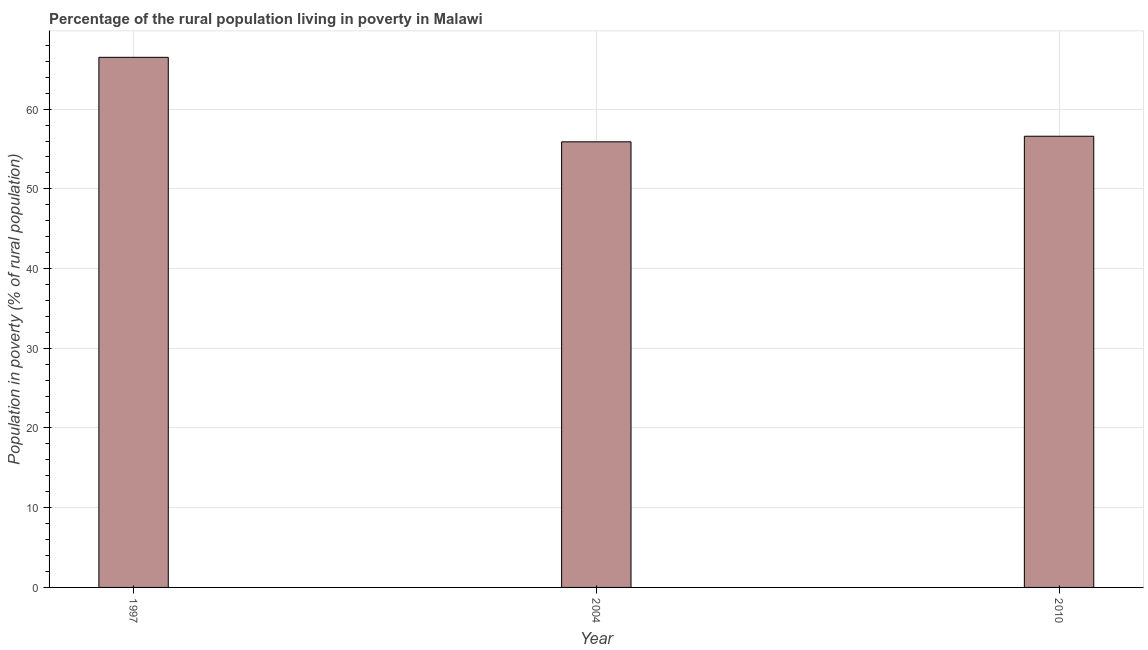What is the title of the graph?
Ensure brevity in your answer.  Percentage of the rural population living in poverty in Malawi. What is the label or title of the X-axis?
Provide a short and direct response. Year. What is the label or title of the Y-axis?
Provide a short and direct response. Population in poverty (% of rural population). What is the percentage of rural population living below poverty line in 2004?
Make the answer very short. 55.9. Across all years, what is the maximum percentage of rural population living below poverty line?
Your response must be concise. 66.5. Across all years, what is the minimum percentage of rural population living below poverty line?
Keep it short and to the point. 55.9. In which year was the percentage of rural population living below poverty line maximum?
Provide a short and direct response. 1997. In which year was the percentage of rural population living below poverty line minimum?
Provide a short and direct response. 2004. What is the sum of the percentage of rural population living below poverty line?
Provide a succinct answer. 179. What is the difference between the percentage of rural population living below poverty line in 1997 and 2010?
Provide a succinct answer. 9.9. What is the average percentage of rural population living below poverty line per year?
Make the answer very short. 59.67. What is the median percentage of rural population living below poverty line?
Make the answer very short. 56.6. In how many years, is the percentage of rural population living below poverty line greater than 18 %?
Your answer should be very brief. 3. Do a majority of the years between 2010 and 2004 (inclusive) have percentage of rural population living below poverty line greater than 38 %?
Your response must be concise. No. What is the ratio of the percentage of rural population living below poverty line in 1997 to that in 2004?
Offer a very short reply. 1.19. Is the difference between the percentage of rural population living below poverty line in 1997 and 2010 greater than the difference between any two years?
Your answer should be very brief. No. What is the difference between the highest and the second highest percentage of rural population living below poverty line?
Offer a very short reply. 9.9. Is the sum of the percentage of rural population living below poverty line in 2004 and 2010 greater than the maximum percentage of rural population living below poverty line across all years?
Make the answer very short. Yes. How many bars are there?
Your response must be concise. 3. Are all the bars in the graph horizontal?
Your response must be concise. No. How many years are there in the graph?
Offer a terse response. 3. What is the difference between two consecutive major ticks on the Y-axis?
Your response must be concise. 10. Are the values on the major ticks of Y-axis written in scientific E-notation?
Your answer should be very brief. No. What is the Population in poverty (% of rural population) in 1997?
Your answer should be very brief. 66.5. What is the Population in poverty (% of rural population) in 2004?
Provide a succinct answer. 55.9. What is the Population in poverty (% of rural population) in 2010?
Ensure brevity in your answer.  56.6. What is the difference between the Population in poverty (% of rural population) in 1997 and 2004?
Make the answer very short. 10.6. What is the difference between the Population in poverty (% of rural population) in 1997 and 2010?
Offer a terse response. 9.9. What is the difference between the Population in poverty (% of rural population) in 2004 and 2010?
Provide a short and direct response. -0.7. What is the ratio of the Population in poverty (% of rural population) in 1997 to that in 2004?
Your answer should be compact. 1.19. What is the ratio of the Population in poverty (% of rural population) in 1997 to that in 2010?
Provide a succinct answer. 1.18. 